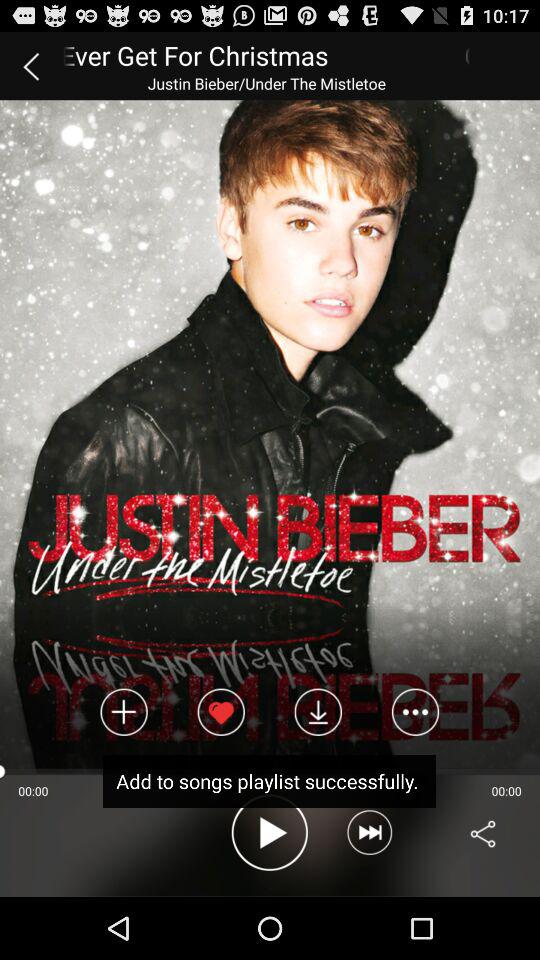What is the album name? The album name is "Under The Mistletoe". 